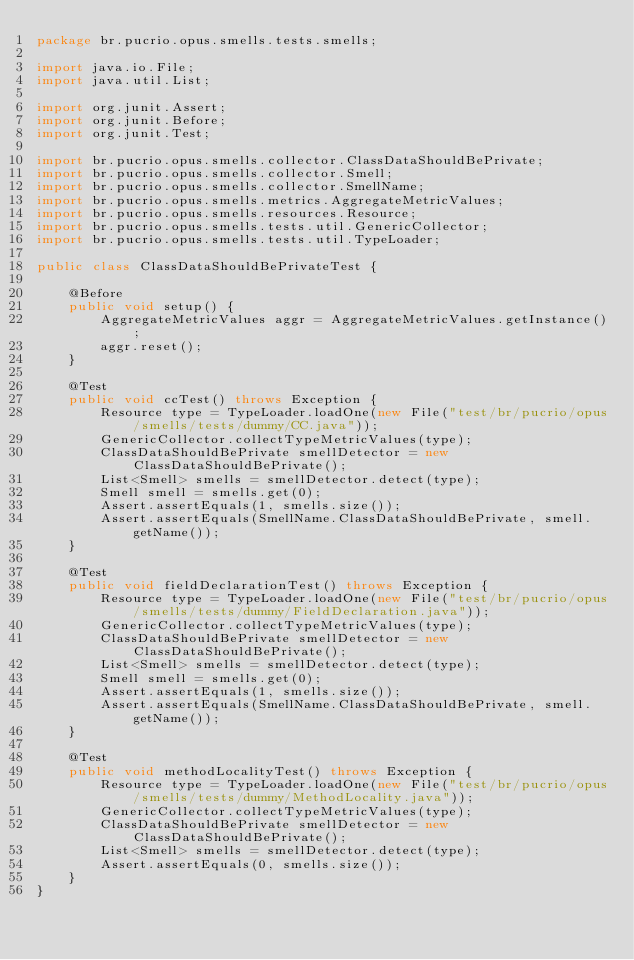<code> <loc_0><loc_0><loc_500><loc_500><_Java_>package br.pucrio.opus.smells.tests.smells;

import java.io.File;
import java.util.List;

import org.junit.Assert;
import org.junit.Before;
import org.junit.Test;

import br.pucrio.opus.smells.collector.ClassDataShouldBePrivate;
import br.pucrio.opus.smells.collector.Smell;
import br.pucrio.opus.smells.collector.SmellName;
import br.pucrio.opus.smells.metrics.AggregateMetricValues;
import br.pucrio.opus.smells.resources.Resource;
import br.pucrio.opus.smells.tests.util.GenericCollector;
import br.pucrio.opus.smells.tests.util.TypeLoader;

public class ClassDataShouldBePrivateTest {
	
	@Before
	public void setup() {
		AggregateMetricValues aggr = AggregateMetricValues.getInstance();
		aggr.reset();
	}

	@Test
	public void ccTest() throws Exception {
		Resource type = TypeLoader.loadOne(new File("test/br/pucrio/opus/smells/tests/dummy/CC.java"));
		GenericCollector.collectTypeMetricValues(type);
		ClassDataShouldBePrivate smellDetector = new ClassDataShouldBePrivate();
		List<Smell> smells = smellDetector.detect(type);
		Smell smell = smells.get(0);
		Assert.assertEquals(1, smells.size());
		Assert.assertEquals(SmellName.ClassDataShouldBePrivate, smell.getName());
	}
	
	@Test
	public void fieldDeclarationTest() throws Exception {
		Resource type = TypeLoader.loadOne(new File("test/br/pucrio/opus/smells/tests/dummy/FieldDeclaration.java"));
		GenericCollector.collectTypeMetricValues(type);
		ClassDataShouldBePrivate smellDetector = new ClassDataShouldBePrivate();
		List<Smell> smells = smellDetector.detect(type);
		Smell smell = smells.get(0);
		Assert.assertEquals(1, smells.size());
		Assert.assertEquals(SmellName.ClassDataShouldBePrivate, smell.getName());
	}
	
	@Test
	public void methodLocalityTest() throws Exception {
		Resource type = TypeLoader.loadOne(new File("test/br/pucrio/opus/smells/tests/dummy/MethodLocality.java"));
		GenericCollector.collectTypeMetricValues(type);
		ClassDataShouldBePrivate smellDetector = new ClassDataShouldBePrivate();
		List<Smell> smells = smellDetector.detect(type);
		Assert.assertEquals(0, smells.size());
	}
}
</code> 